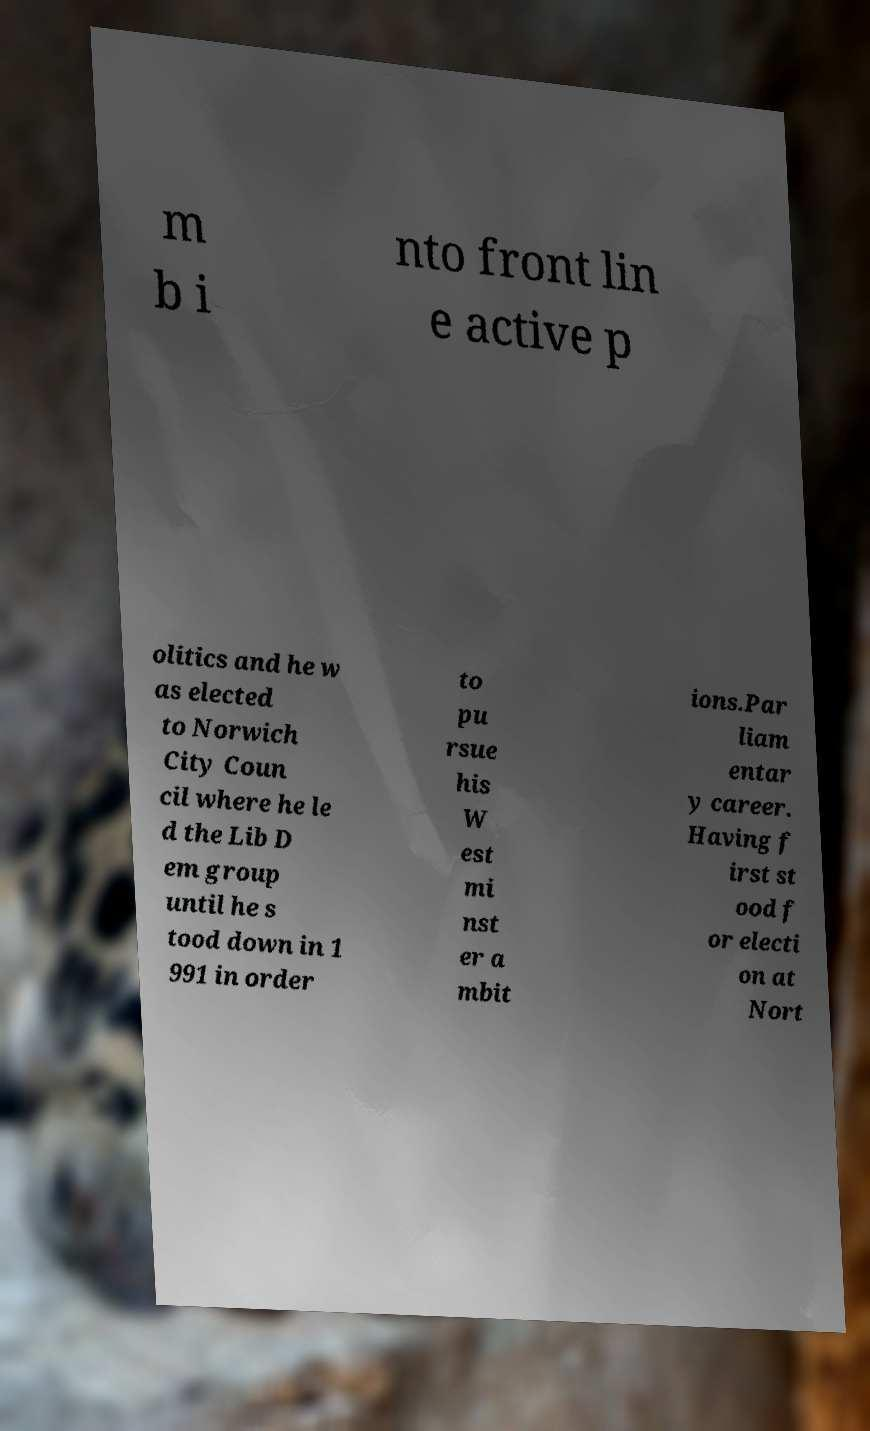For documentation purposes, I need the text within this image transcribed. Could you provide that? m b i nto front lin e active p olitics and he w as elected to Norwich City Coun cil where he le d the Lib D em group until he s tood down in 1 991 in order to pu rsue his W est mi nst er a mbit ions.Par liam entar y career. Having f irst st ood f or electi on at Nort 